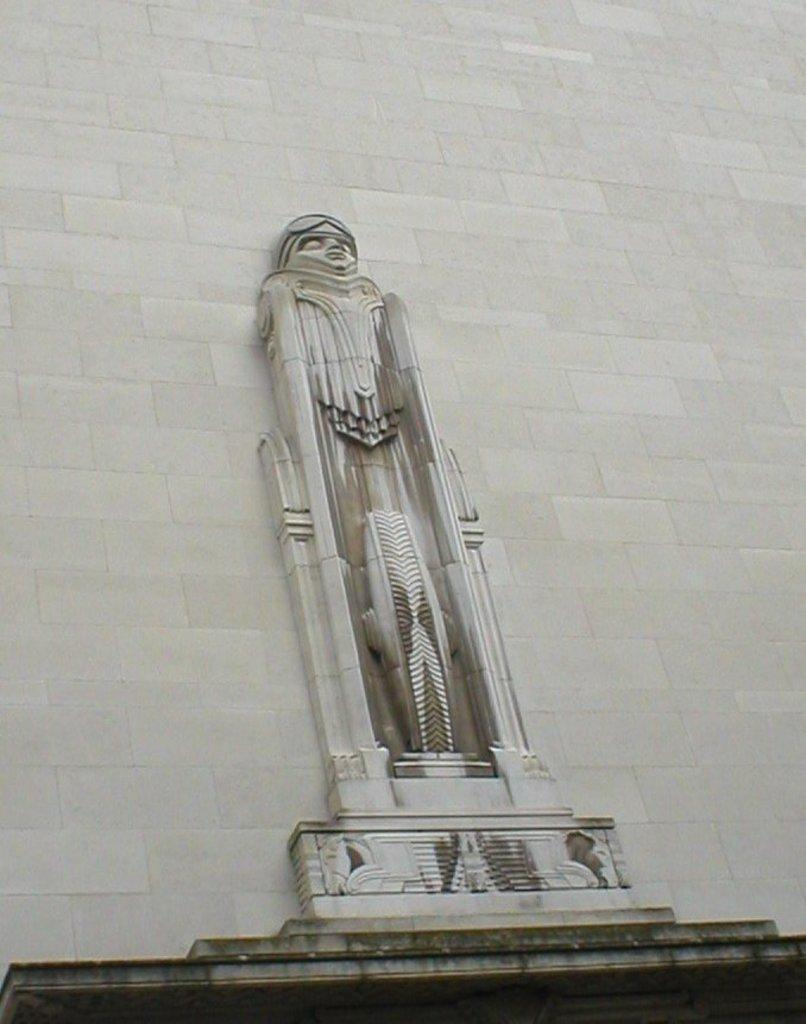What is the main subject in the image? There is a statue in the image. Can you describe the setting of the image? There is a wall in the background of the image. How many frogs are sitting on the statue in the image? There are no frogs present in the image; it only features a statue and a wall in the background. 